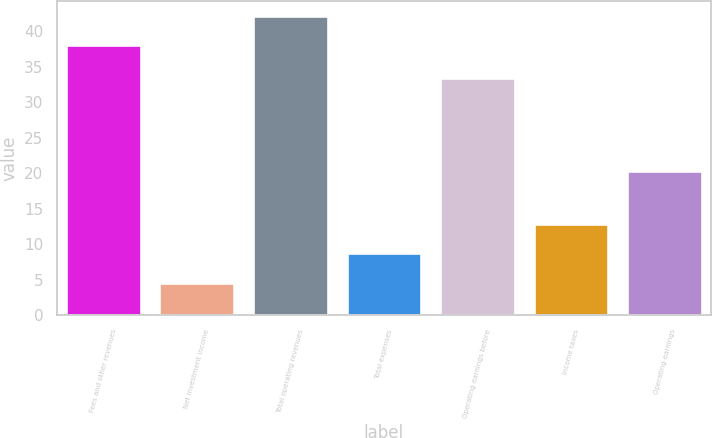Convert chart to OTSL. <chart><loc_0><loc_0><loc_500><loc_500><bar_chart><fcel>Fees and other revenues<fcel>Net investment income<fcel>Total operating revenues<fcel>Total expenses<fcel>Operating earnings before<fcel>Income taxes<fcel>Operating earnings<nl><fcel>38<fcel>4.56<fcel>42.16<fcel>8.72<fcel>33.4<fcel>12.88<fcel>20.3<nl></chart> 